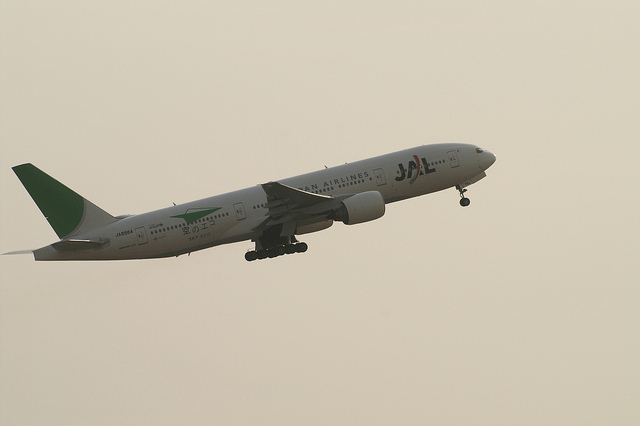Read and extract the text from this image. AIRLINES JAL 